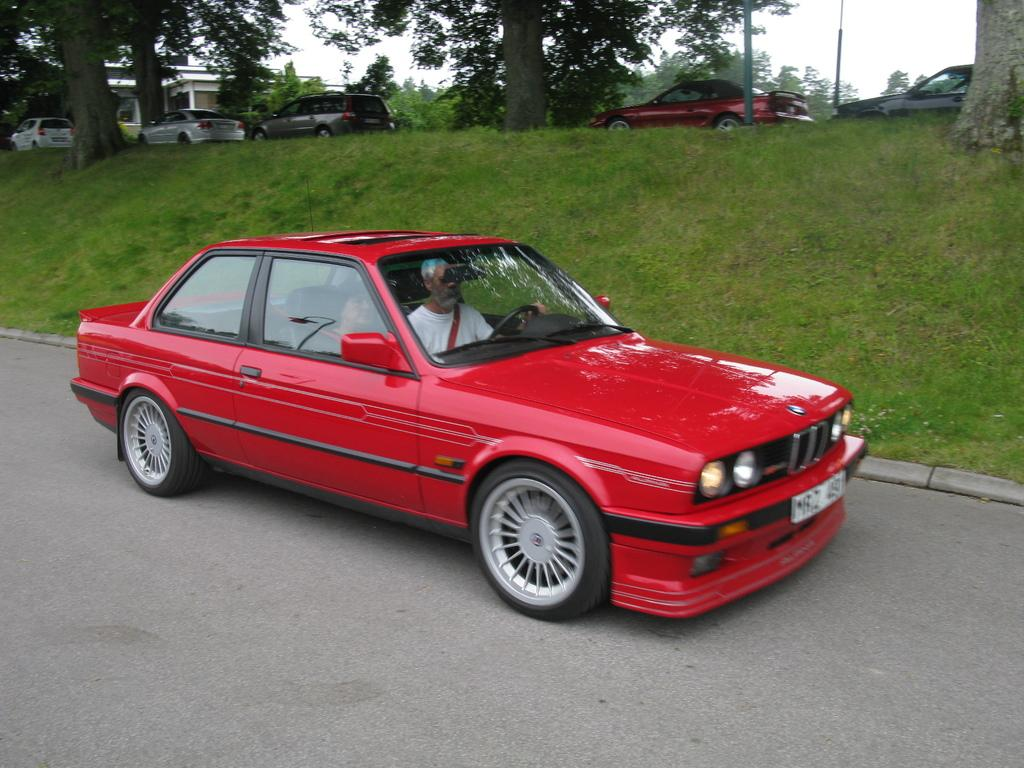How many people are in the car in the image? There are two persons sitting in a car in the image. What type of natural environment can be seen in the image? There is grass and trees visible in the image. What else can be seen in the image besides the car and people? There are other vehicles in the image. What is visible in the background of the image? The sky is visible in the image. What type of paper is being used by the legs of the persons in the image? There is no paper or mention of legs in the image; it features two persons sitting in a car with other vehicles and a natural environment in the background. 